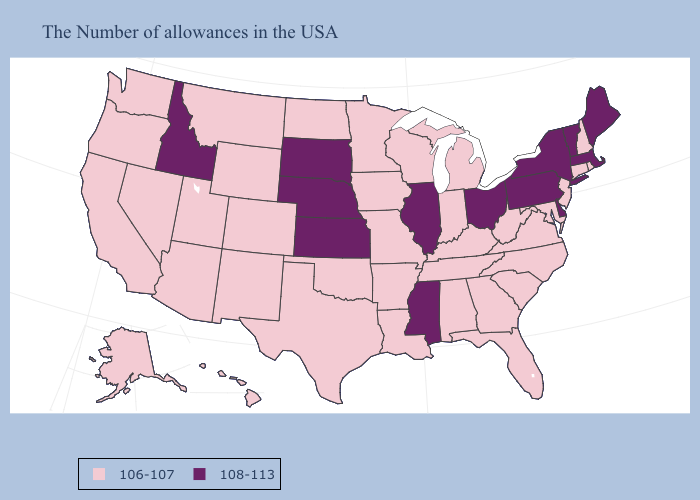Among the states that border Rhode Island , which have the lowest value?
Quick response, please. Connecticut. Does Kentucky have the lowest value in the South?
Short answer required. Yes. Does Mississippi have the lowest value in the South?
Concise answer only. No. Does Nevada have a higher value than Michigan?
Short answer required. No. What is the value of South Dakota?
Concise answer only. 108-113. Does Iowa have the highest value in the MidWest?
Short answer required. No. What is the value of California?
Quick response, please. 106-107. What is the value of Florida?
Answer briefly. 106-107. How many symbols are there in the legend?
Keep it brief. 2. What is the value of Wyoming?
Quick response, please. 106-107. Name the states that have a value in the range 106-107?
Give a very brief answer. Rhode Island, New Hampshire, Connecticut, New Jersey, Maryland, Virginia, North Carolina, South Carolina, West Virginia, Florida, Georgia, Michigan, Kentucky, Indiana, Alabama, Tennessee, Wisconsin, Louisiana, Missouri, Arkansas, Minnesota, Iowa, Oklahoma, Texas, North Dakota, Wyoming, Colorado, New Mexico, Utah, Montana, Arizona, Nevada, California, Washington, Oregon, Alaska, Hawaii. What is the highest value in the USA?
Give a very brief answer. 108-113. What is the value of Massachusetts?
Give a very brief answer. 108-113. Among the states that border North Carolina , which have the highest value?
Concise answer only. Virginia, South Carolina, Georgia, Tennessee. 